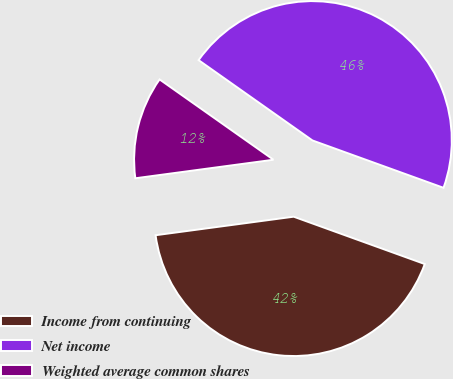<chart> <loc_0><loc_0><loc_500><loc_500><pie_chart><fcel>Income from continuing<fcel>Net income<fcel>Weighted average common shares<nl><fcel>42.36%<fcel>45.74%<fcel>11.9%<nl></chart> 